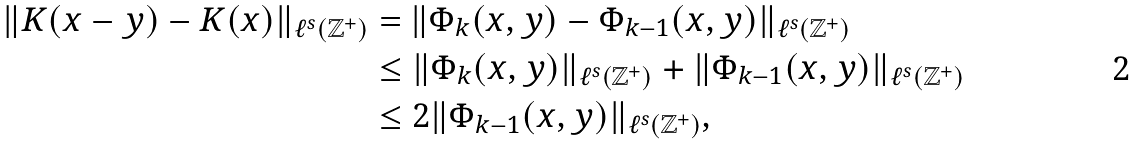Convert formula to latex. <formula><loc_0><loc_0><loc_500><loc_500>\| K ( x - y ) - K ( x ) \| _ { \ell ^ { s } ( \mathbb { Z } ^ { + } ) } & = \| \Phi _ { k } ( x , y ) - \Phi _ { k - 1 } ( x , y ) \| _ { \ell ^ { s } ( \mathbb { Z } ^ { + } ) } \\ & \leq \| \Phi _ { k } ( x , y ) \| _ { \ell ^ { s } ( \mathbb { Z } ^ { + } ) } + \| \Phi _ { k - 1 } ( x , y ) \| _ { \ell ^ { s } ( \mathbb { Z } ^ { + } ) } \\ & \leq 2 \| \Phi _ { k - 1 } ( x , y ) \| _ { \ell ^ { s } ( \mathbb { Z } ^ { + } ) } ,</formula> 